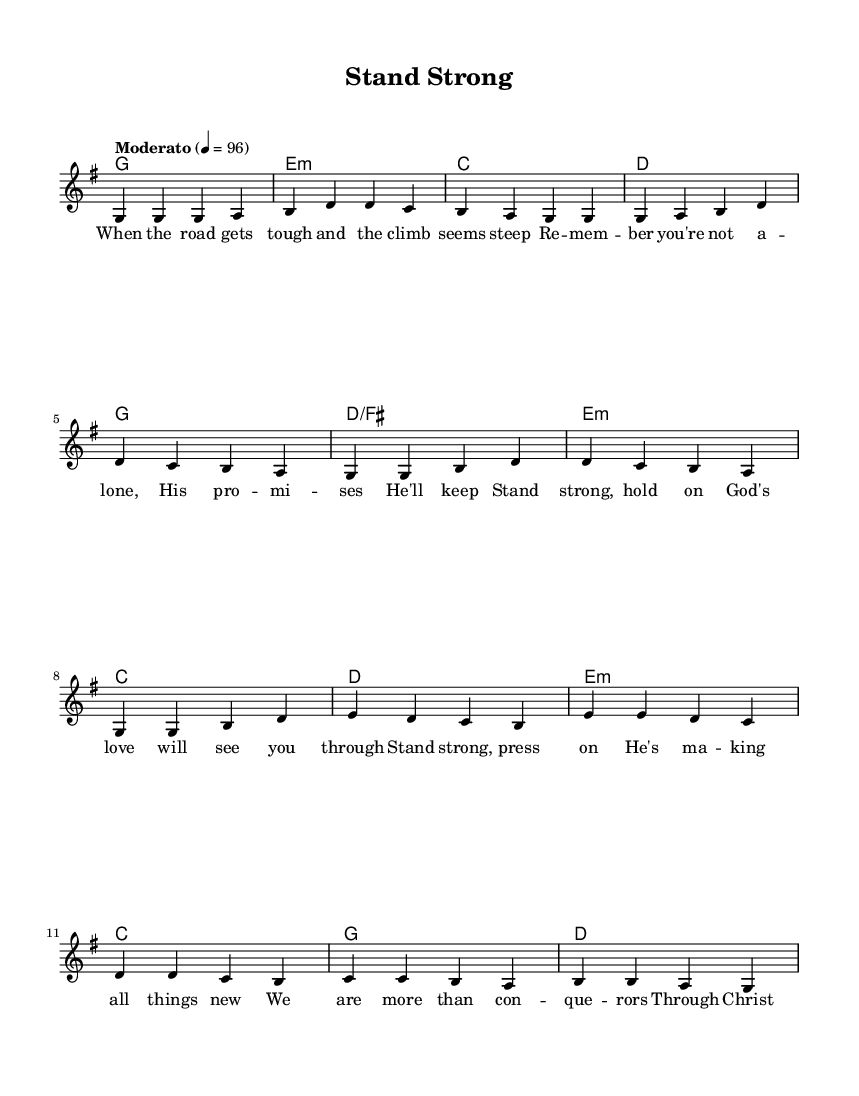What is the key signature of this music? The key signature is G major, which has one sharp. This can be found at the beginning of the sheet music, where a sharp symbol appears on the F line of the staff.
Answer: G major What is the time signature of this music? The time signature is 4/4, indicated at the beginning of the score. It tells you that there are four beats in each measure and the quarter note receives one beat.
Answer: 4/4 What is the tempo marking for this piece? The tempo marking is "Moderato" with a metronome marking of 96. The tempo is indicated at the beginning, guiding the overall speed of the music.
Answer: Moderato Which chord comes at the beginning of the bridge? The chord at the beginning of the bridge is E minor, located in the harmonies section just before the bridge lyrics. It provides the harmonic foundation for this part of the song.
Answer: E minor How many measures are in the chorus? There are four measures in the chorus, as seen by counting grouped sets of vertical lines that separate the measures in the melody and harmony sections.
Answer: Four What is the theme of the lyrics in this piece? The theme of the lyrics is about overcoming challenges and finding strength in faith. This can be inferred from phrases like "Stand strong" and "God's love will see you through," highlighting perseverance and spiritual support.
Answer: Overcoming challenges 